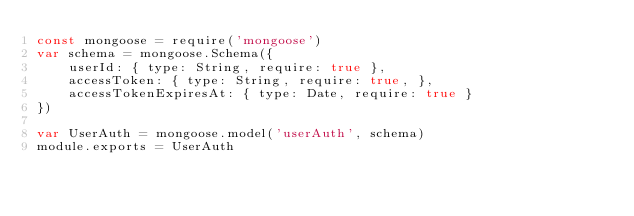<code> <loc_0><loc_0><loc_500><loc_500><_JavaScript_>const mongoose = require('mongoose')
var schema = mongoose.Schema({
    userId: { type: String, require: true },
    accessToken: { type: String, require: true, },
    accessTokenExpiresAt: { type: Date, require: true }
})

var UserAuth = mongoose.model('userAuth', schema)
module.exports = UserAuth</code> 